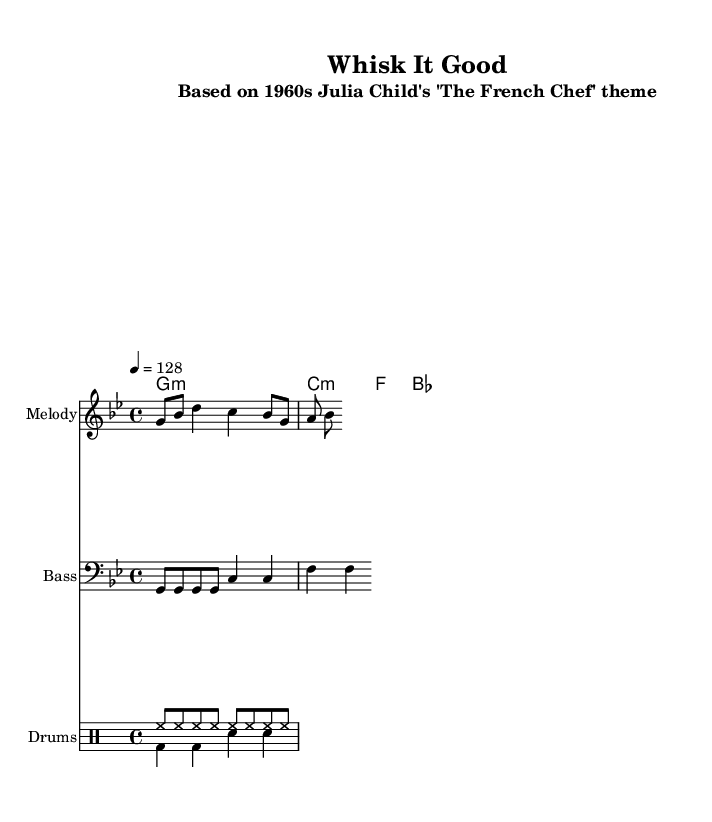What is the key signature of this music? The key signature is G minor, which has two flats (B flat and E flat). This is indicated by the `\key g \minor` line in the `global` section of the code.
Answer: G minor What is the time signature of this music? The time signature is 4/4, which indicates four beats per measure and a quarter note gets one beat. This is noted in the `\time 4/4` line in the `global` section.
Answer: 4/4 What is the tempo marking indicated in the score? The tempo marking indicates a speed of 128 beats per minute, specified by the `\tempo 4 = 128` line within the `global` section.
Answer: 128 What is the first note of the melody? The first note of the melody is G, as shown at the beginning of the melody part. It is the first note in the `\relative c''` section, represented as `g8`.
Answer: G How many measures are in the harmony section? There are four measures in the harmony section, derived from counting the `g1:m` and `bes1` along with the two measures of `c2:m f2` in the `\chordmode` section.
Answer: 4 How do the drum parts divide the beats? The drum parts divide the beats by featuring eight hi-hat hits and alternating between bass drum and snare drum in the downbeat, giving a dance rhythm that relies on both hi-hat and kick-snap patterns. The hi-hats are `hh8` indicating eighth notes and the bass/snare pattern indicates half notes.
Answer: Alternating What style is this music based on? This music is based on the vintage cooking show theme from the 1960s, specifically Julia Child's 'The French Chef', as mentioned in the subtitle of the score.
Answer: Vintage cooking show theme 